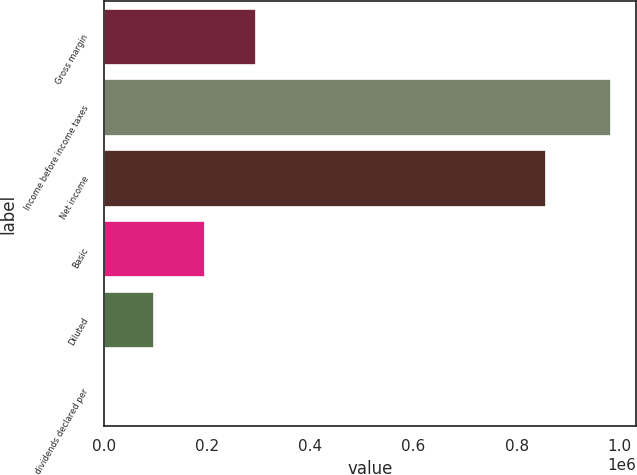<chart> <loc_0><loc_0><loc_500><loc_500><bar_chart><fcel>Gross margin<fcel>Income before income taxes<fcel>Net income<fcel>Basic<fcel>Diluted<fcel>Cash dividends declared per<nl><fcel>294763<fcel>982542<fcel>855984<fcel>196508<fcel>98254.3<fcel>0.07<nl></chart> 